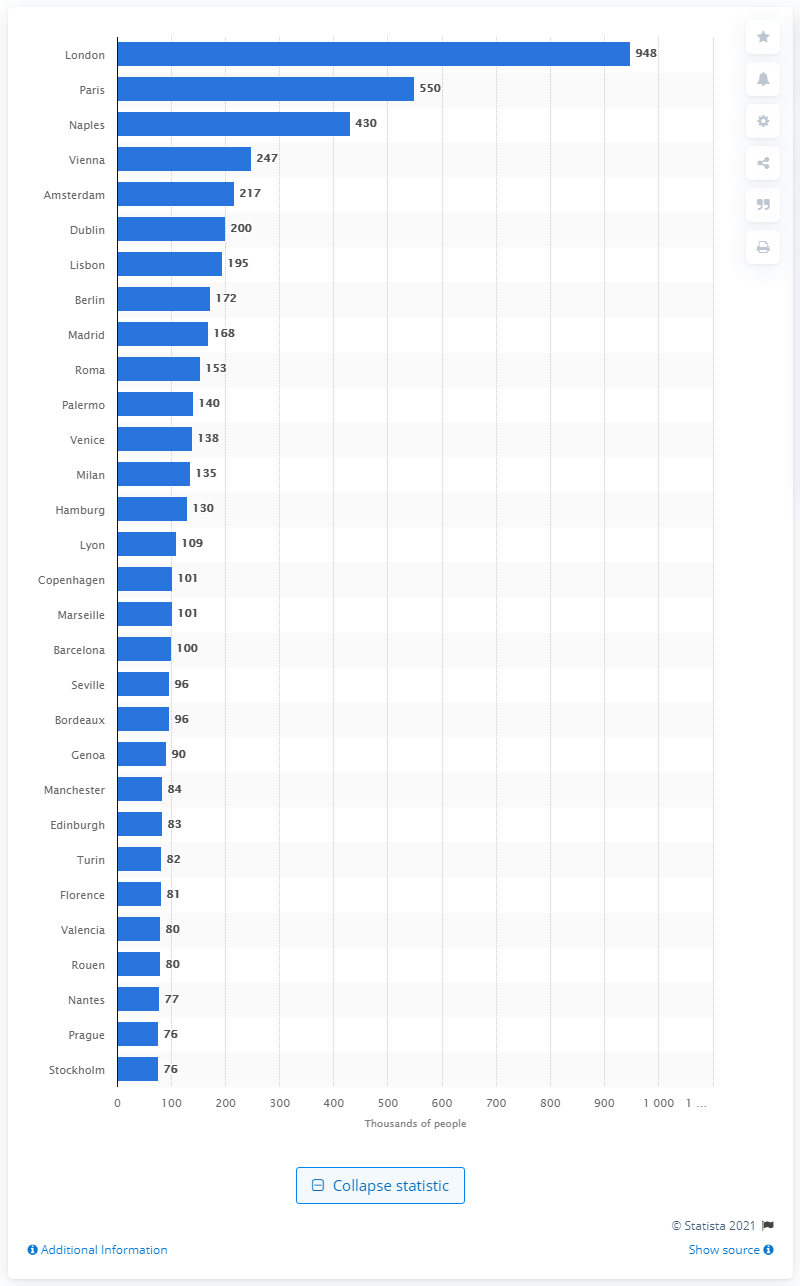Outline some significant characteristics in this image. In the year 1800, London was the largest city in Western Europe. Naples was the third largest city in Western Europe in the year 1800. 